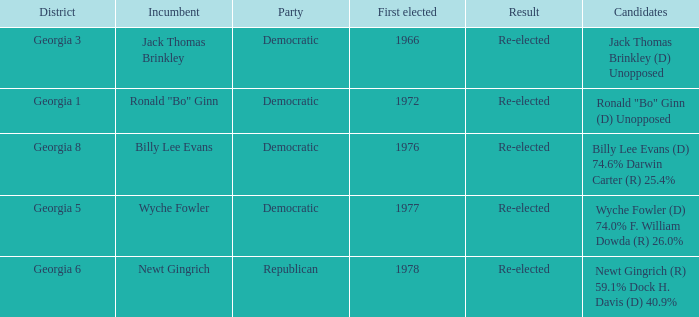What is the party with the candidates newt gingrich (r) 59.1% dock h. davis (d) 40.9%? Republican. Can you parse all the data within this table? {'header': ['District', 'Incumbent', 'Party', 'First elected', 'Result', 'Candidates'], 'rows': [['Georgia 3', 'Jack Thomas Brinkley', 'Democratic', '1966', 'Re-elected', 'Jack Thomas Brinkley (D) Unopposed'], ['Georgia 1', 'Ronald "Bo" Ginn', 'Democratic', '1972', 'Re-elected', 'Ronald "Bo" Ginn (D) Unopposed'], ['Georgia 8', 'Billy Lee Evans', 'Democratic', '1976', 'Re-elected', 'Billy Lee Evans (D) 74.6% Darwin Carter (R) 25.4%'], ['Georgia 5', 'Wyche Fowler', 'Democratic', '1977', 'Re-elected', 'Wyche Fowler (D) 74.0% F. William Dowda (R) 26.0%'], ['Georgia 6', 'Newt Gingrich', 'Republican', '1978', 'Re-elected', 'Newt Gingrich (R) 59.1% Dock H. Davis (D) 40.9%']]} 